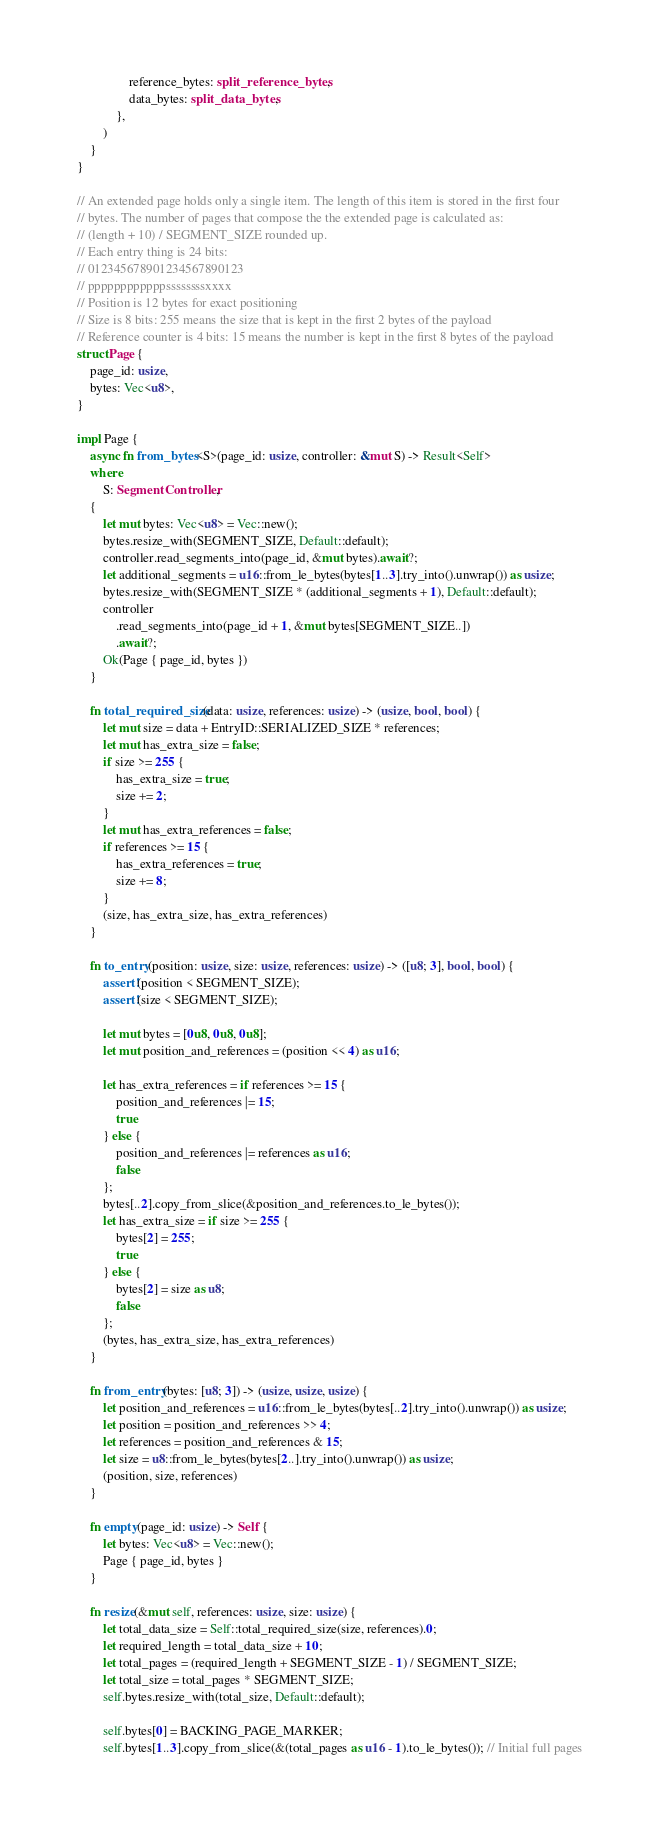Convert code to text. <code><loc_0><loc_0><loc_500><loc_500><_Rust_>                reference_bytes: split_reference_bytes,
                data_bytes: split_data_bytes,
            },
        )
    }
}

// An extended page holds only a single item. The length of this item is stored in the first four
// bytes. The number of pages that compose the the extended page is calculated as:
// (length + 10) / SEGMENT_SIZE rounded up.
// Each entry thing is 24 bits:
// 012345678901234567890123
// ppppppppppppssssssssxxxx
// Position is 12 bytes for exact positioning
// Size is 8 bits: 255 means the size that is kept in the first 2 bytes of the payload
// Reference counter is 4 bits: 15 means the number is kept in the first 8 bytes of the payload
struct Page {
    page_id: usize,
    bytes: Vec<u8>,
}

impl Page {
    async fn from_bytes<S>(page_id: usize, controller: &mut S) -> Result<Self>
    where
        S: SegmentController,
    {
        let mut bytes: Vec<u8> = Vec::new();
        bytes.resize_with(SEGMENT_SIZE, Default::default);
        controller.read_segments_into(page_id, &mut bytes).await?;
        let additional_segments = u16::from_le_bytes(bytes[1..3].try_into().unwrap()) as usize;
        bytes.resize_with(SEGMENT_SIZE * (additional_segments + 1), Default::default);
        controller
            .read_segments_into(page_id + 1, &mut bytes[SEGMENT_SIZE..])
            .await?;
        Ok(Page { page_id, bytes })
    }

    fn total_required_size(data: usize, references: usize) -> (usize, bool, bool) {
        let mut size = data + EntryID::SERIALIZED_SIZE * references;
        let mut has_extra_size = false;
        if size >= 255 {
            has_extra_size = true;
            size += 2;
        }
        let mut has_extra_references = false;
        if references >= 15 {
            has_extra_references = true;
            size += 8;
        }
        (size, has_extra_size, has_extra_references)
    }

    fn to_entry(position: usize, size: usize, references: usize) -> ([u8; 3], bool, bool) {
        assert!(position < SEGMENT_SIZE);
        assert!(size < SEGMENT_SIZE);

        let mut bytes = [0u8, 0u8, 0u8];
        let mut position_and_references = (position << 4) as u16;

        let has_extra_references = if references >= 15 {
            position_and_references |= 15;
            true
        } else {
            position_and_references |= references as u16;
            false
        };
        bytes[..2].copy_from_slice(&position_and_references.to_le_bytes());
        let has_extra_size = if size >= 255 {
            bytes[2] = 255;
            true
        } else {
            bytes[2] = size as u8;
            false
        };
        (bytes, has_extra_size, has_extra_references)
    }

    fn from_entry(bytes: [u8; 3]) -> (usize, usize, usize) {
        let position_and_references = u16::from_le_bytes(bytes[..2].try_into().unwrap()) as usize;
        let position = position_and_references >> 4;
        let references = position_and_references & 15;
        let size = u8::from_le_bytes(bytes[2..].try_into().unwrap()) as usize;
        (position, size, references)
    }

    fn empty(page_id: usize) -> Self {
        let bytes: Vec<u8> = Vec::new();
        Page { page_id, bytes }
    }

    fn resize(&mut self, references: usize, size: usize) {
        let total_data_size = Self::total_required_size(size, references).0;
        let required_length = total_data_size + 10;
        let total_pages = (required_length + SEGMENT_SIZE - 1) / SEGMENT_SIZE;
        let total_size = total_pages * SEGMENT_SIZE;
        self.bytes.resize_with(total_size, Default::default);

        self.bytes[0] = BACKING_PAGE_MARKER;
        self.bytes[1..3].copy_from_slice(&(total_pages as u16 - 1).to_le_bytes()); // Initial full pages</code> 